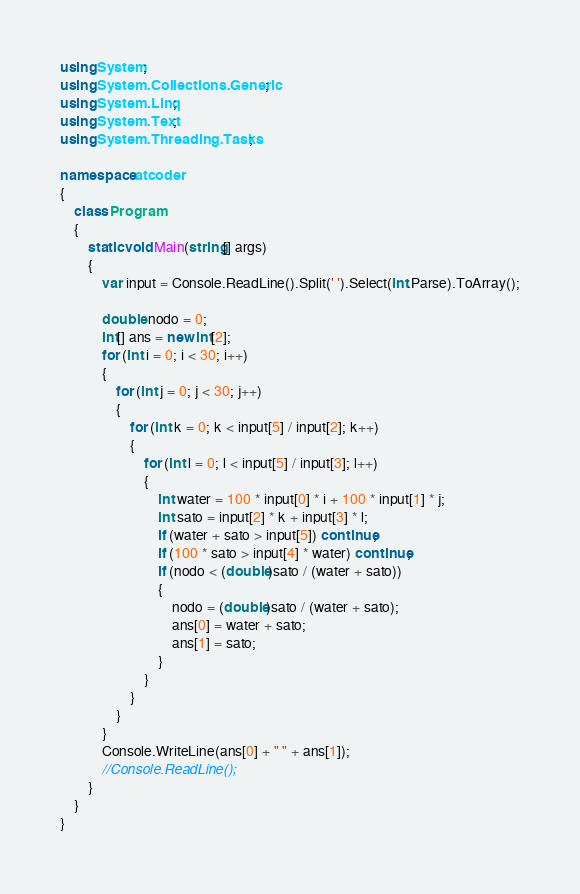Convert code to text. <code><loc_0><loc_0><loc_500><loc_500><_C#_>using System;
using System.Collections.Generic;
using System.Linq;
using System.Text;
using System.Threading.Tasks;

namespace atcoder
{
	class Program
	{
		static void Main(string[] args)
		{
			var input = Console.ReadLine().Split(' ').Select(int.Parse).ToArray();

			double nodo = 0;
			int[] ans = new int[2];
			for (int i = 0; i < 30; i++)
			{
				for (int j = 0; j < 30; j++)
				{
					for (int k = 0; k < input[5] / input[2]; k++)
					{
						for (int l = 0; l < input[5] / input[3]; l++)
						{
							int water = 100 * input[0] * i + 100 * input[1] * j;
							int sato = input[2] * k + input[3] * l;
							if (water + sato > input[5]) continue;
							if (100 * sato > input[4] * water) continue;
							if (nodo < (double)sato / (water + sato))
							{
								nodo = (double)sato / (water + sato);
								ans[0] = water + sato;
								ans[1] = sato;
							}
						}
					}
				}
			}
			Console.WriteLine(ans[0] + " " + ans[1]);
			//Console.ReadLine();
		}
	}
}</code> 